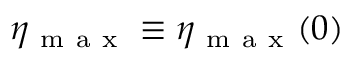<formula> <loc_0><loc_0><loc_500><loc_500>\eta _ { m a x } \equiv \eta _ { m a x } ( 0 )</formula> 